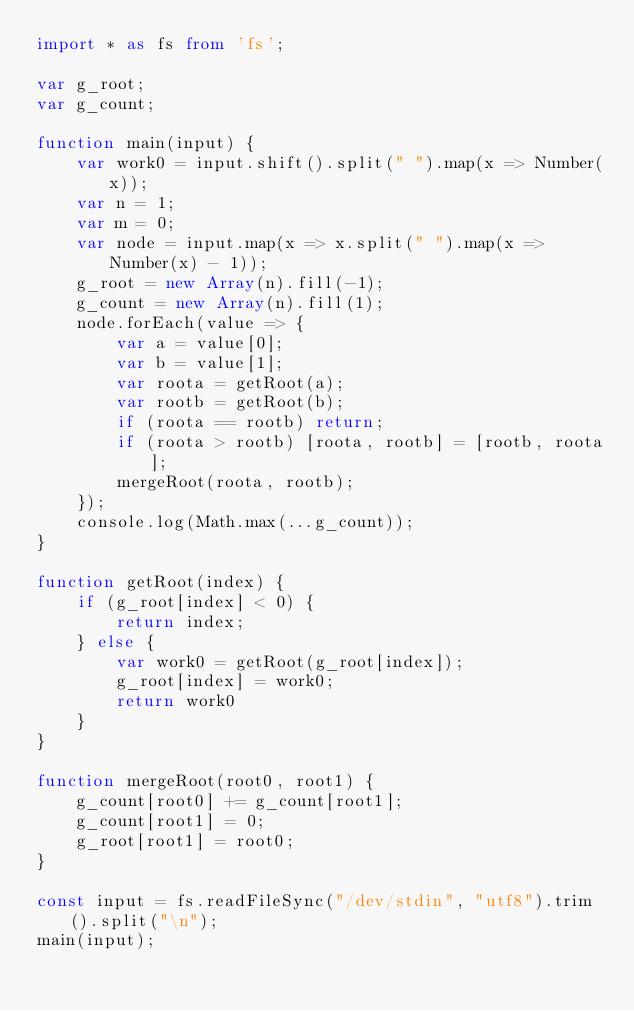<code> <loc_0><loc_0><loc_500><loc_500><_TypeScript_>import * as fs from 'fs';

var g_root;
var g_count;

function main(input) {
	var work0 = input.shift().split(" ").map(x => Number(x));
	var n = 1;
	var m = 0;
	var node = input.map(x => x.split(" ").map(x => Number(x) - 1));
	g_root = new Array(n).fill(-1);
	g_count = new Array(n).fill(1);
	node.forEach(value => {
		var a = value[0];
		var b = value[1];
		var roota = getRoot(a);
		var rootb = getRoot(b);
		if (roota == rootb) return;
		if (roota > rootb) [roota, rootb] = [rootb, roota];
		mergeRoot(roota, rootb);
	});
	console.log(Math.max(...g_count));
}

function getRoot(index) {
	if (g_root[index] < 0) {
		return index;
	} else {
		var work0 = getRoot(g_root[index]);
		g_root[index] = work0;
		return work0
	}
}

function mergeRoot(root0, root1) {
	g_count[root0] += g_count[root1];
	g_count[root1] = 0;
	g_root[root1] = root0;
}

const input = fs.readFileSync("/dev/stdin", "utf8").trim().split("\n");
main(input);
</code> 